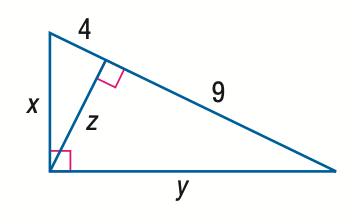Answer the mathemtical geometry problem and directly provide the correct option letter.
Question: Find y.
Choices: A: 6 B: 3 \sqrt { 5 } C: 9 D: 3 \sqrt { 13 } D 